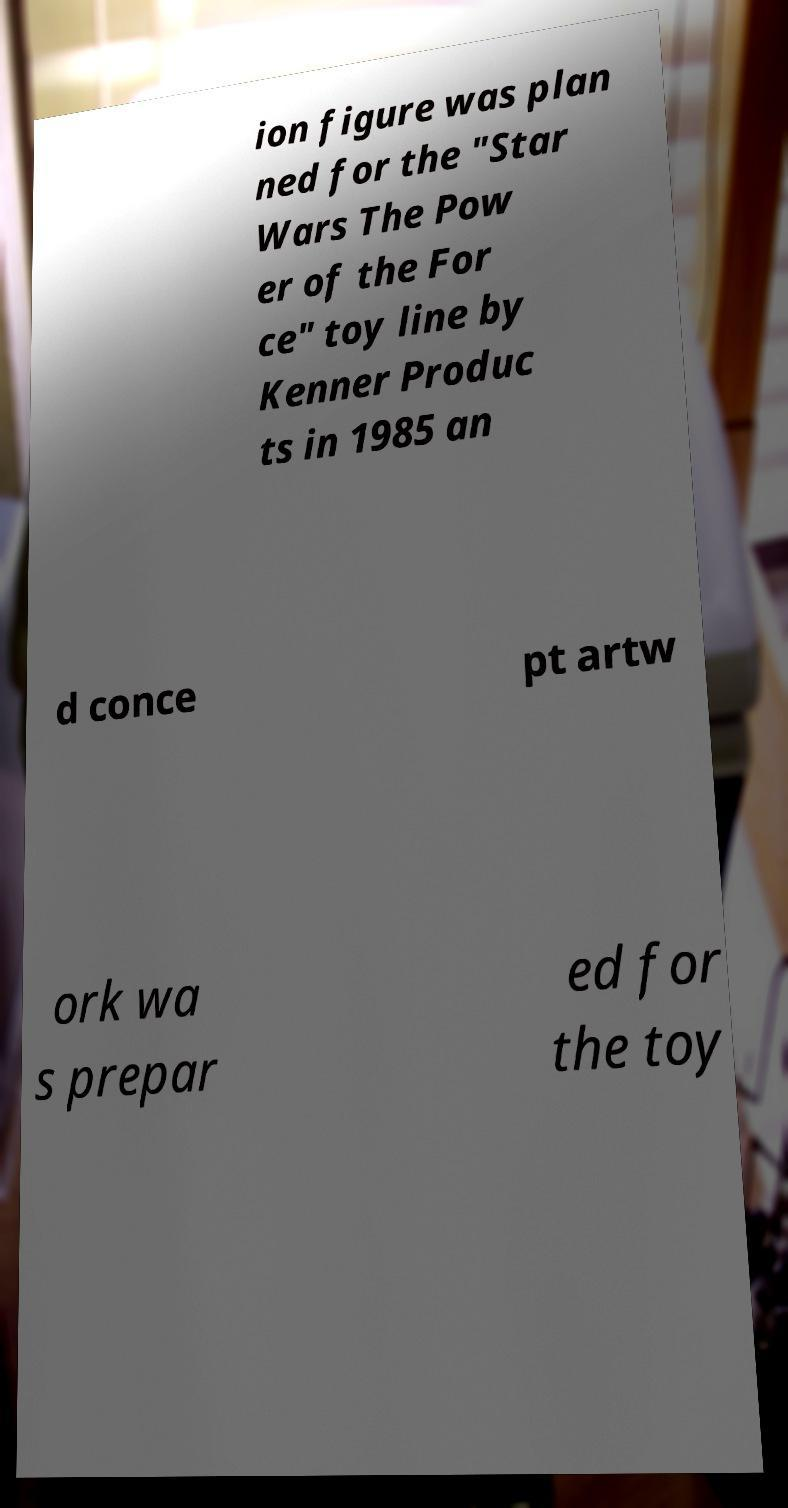Please identify and transcribe the text found in this image. ion figure was plan ned for the "Star Wars The Pow er of the For ce" toy line by Kenner Produc ts in 1985 an d conce pt artw ork wa s prepar ed for the toy 